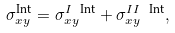Convert formula to latex. <formula><loc_0><loc_0><loc_500><loc_500>\sigma _ { x y } ^ { \text {Int} } = \sigma _ { x y } ^ { I \ \text {Int} } + \sigma _ { x y } ^ { I I \ \text {Int} } ,</formula> 